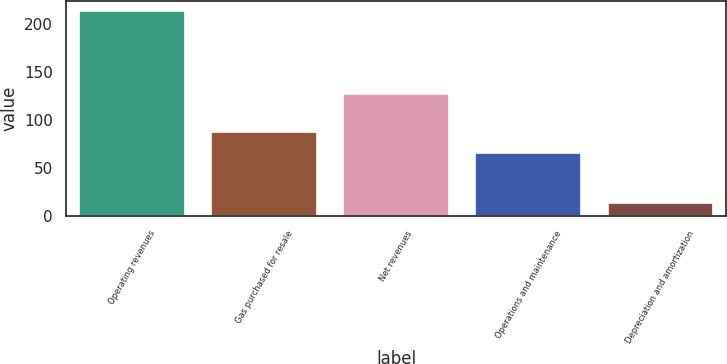Convert chart. <chart><loc_0><loc_0><loc_500><loc_500><bar_chart><fcel>Operating revenues<fcel>Gas purchased for resale<fcel>Net revenues<fcel>Operations and maintenance<fcel>Depreciation and amortization<nl><fcel>214<fcel>87<fcel>127<fcel>66<fcel>13<nl></chart> 